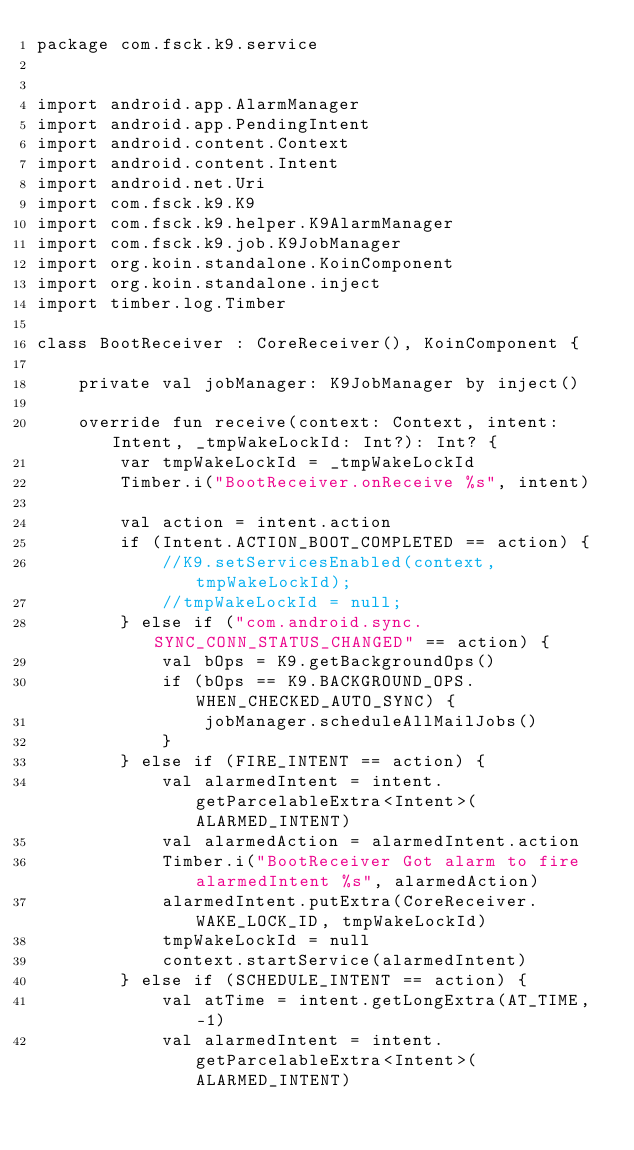Convert code to text. <code><loc_0><loc_0><loc_500><loc_500><_Kotlin_>package com.fsck.k9.service


import android.app.AlarmManager
import android.app.PendingIntent
import android.content.Context
import android.content.Intent
import android.net.Uri
import com.fsck.k9.K9
import com.fsck.k9.helper.K9AlarmManager
import com.fsck.k9.job.K9JobManager
import org.koin.standalone.KoinComponent
import org.koin.standalone.inject
import timber.log.Timber

class BootReceiver : CoreReceiver(), KoinComponent {

    private val jobManager: K9JobManager by inject()

    override fun receive(context: Context, intent: Intent, _tmpWakeLockId: Int?): Int? {
        var tmpWakeLockId = _tmpWakeLockId
        Timber.i("BootReceiver.onReceive %s", intent)

        val action = intent.action
        if (Intent.ACTION_BOOT_COMPLETED == action) {
            //K9.setServicesEnabled(context, tmpWakeLockId);
            //tmpWakeLockId = null;
        } else if ("com.android.sync.SYNC_CONN_STATUS_CHANGED" == action) {
            val bOps = K9.getBackgroundOps()
            if (bOps == K9.BACKGROUND_OPS.WHEN_CHECKED_AUTO_SYNC) {
                jobManager.scheduleAllMailJobs()
            }
        } else if (FIRE_INTENT == action) {
            val alarmedIntent = intent.getParcelableExtra<Intent>(ALARMED_INTENT)
            val alarmedAction = alarmedIntent.action
            Timber.i("BootReceiver Got alarm to fire alarmedIntent %s", alarmedAction)
            alarmedIntent.putExtra(CoreReceiver.WAKE_LOCK_ID, tmpWakeLockId)
            tmpWakeLockId = null
            context.startService(alarmedIntent)
        } else if (SCHEDULE_INTENT == action) {
            val atTime = intent.getLongExtra(AT_TIME, -1)
            val alarmedIntent = intent.getParcelableExtra<Intent>(ALARMED_INTENT)</code> 